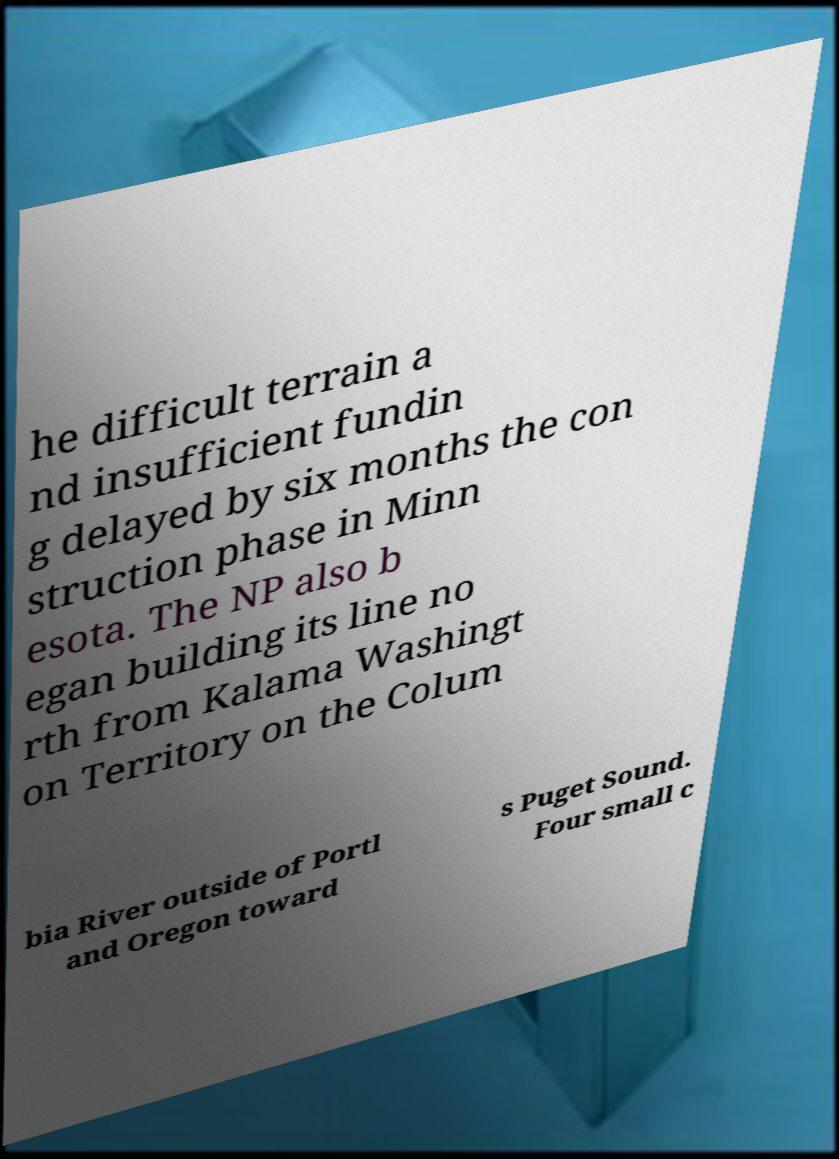Please identify and transcribe the text found in this image. he difficult terrain a nd insufficient fundin g delayed by six months the con struction phase in Minn esota. The NP also b egan building its line no rth from Kalama Washingt on Territory on the Colum bia River outside of Portl and Oregon toward s Puget Sound. Four small c 